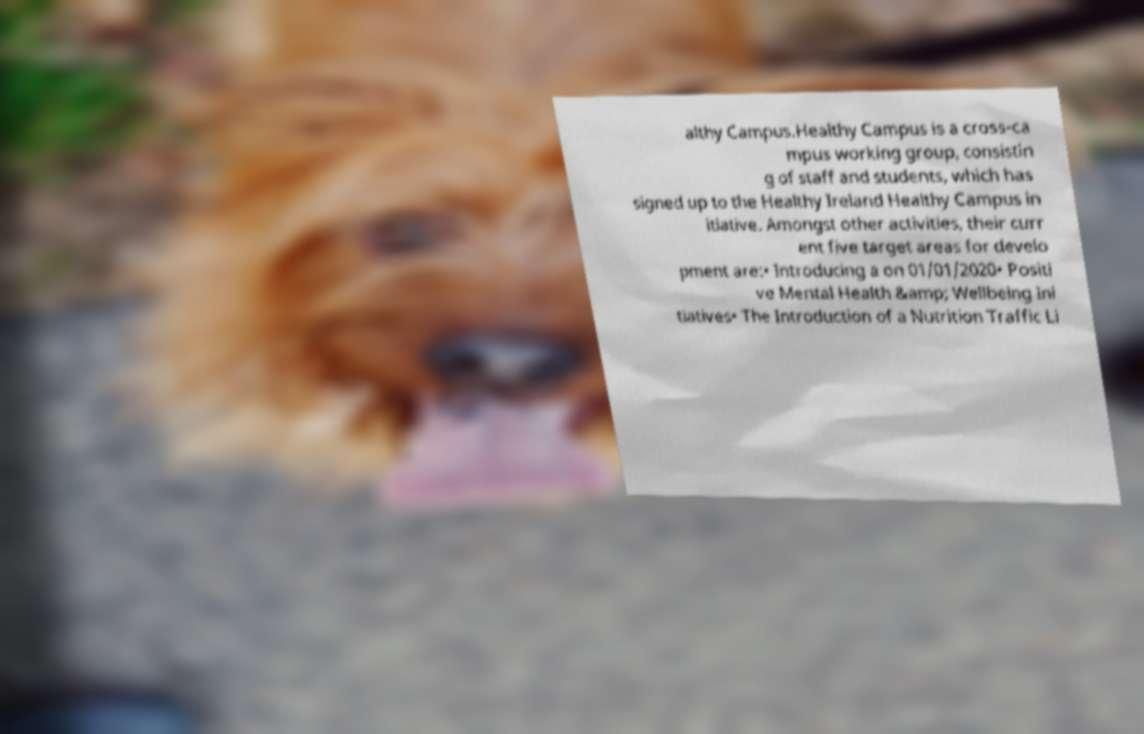Please read and relay the text visible in this image. What does it say? althy Campus.Healthy Campus is a cross-ca mpus working group, consistin g of staff and students, which has signed up to the Healthy Ireland Healthy Campus in itiative. Amongst other activities, their curr ent five target areas for develo pment are:• Introducing a on 01/01/2020• Positi ve Mental Health &amp; Wellbeing Ini tiatives• The Introduction of a Nutrition Traffic Li 